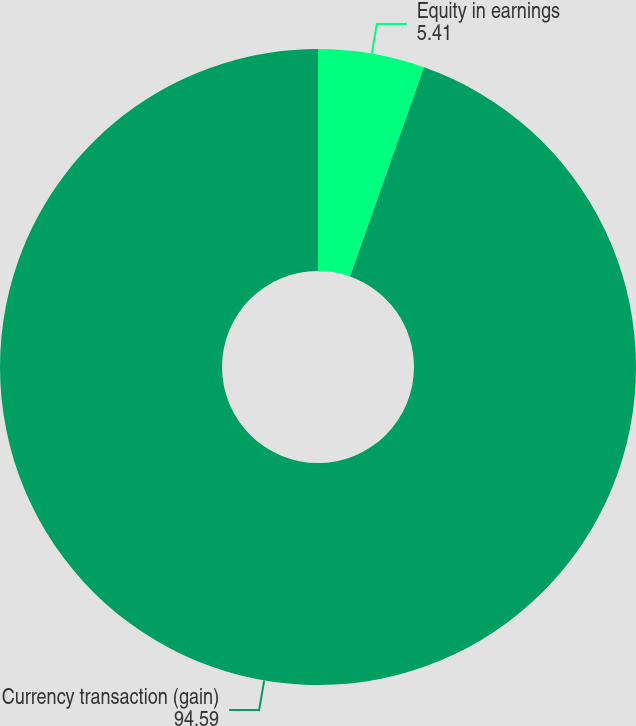Convert chart to OTSL. <chart><loc_0><loc_0><loc_500><loc_500><pie_chart><fcel>Equity in earnings<fcel>Currency transaction (gain)<nl><fcel>5.41%<fcel>94.59%<nl></chart> 